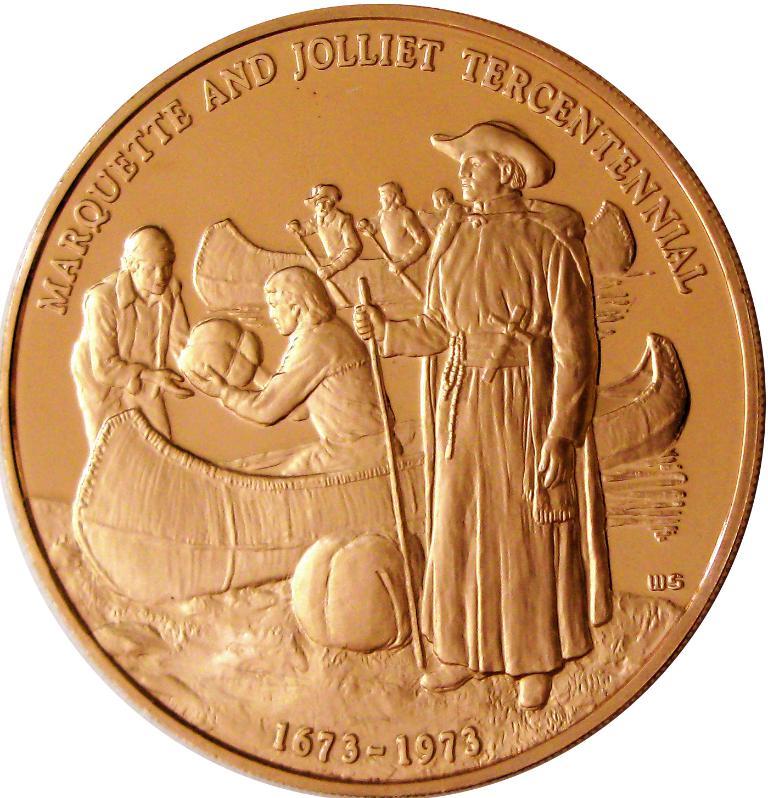When was the coin first minted?
Your answer should be compact. 1673. What are the dates at the bottom of the coin?
Make the answer very short. 1673-1973. 